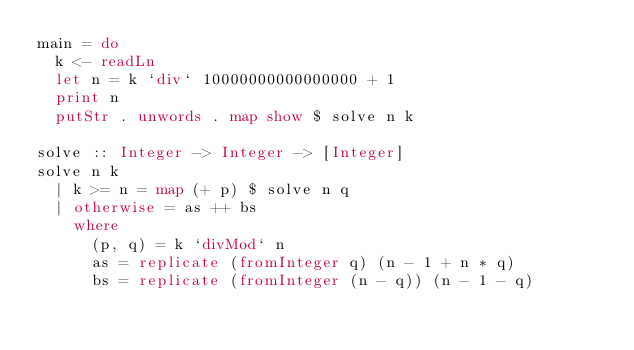<code> <loc_0><loc_0><loc_500><loc_500><_Haskell_>main = do
  k <- readLn
  let n = k `div` 10000000000000000 + 1
  print n
  putStr . unwords . map show $ solve n k
 
solve :: Integer -> Integer -> [Integer]
solve n k
  | k >= n = map (+ p) $ solve n q 
  | otherwise = as ++ bs
    where
      (p, q) = k `divMod` n
      as = replicate (fromInteger q) (n - 1 + n * q)
      bs = replicate (fromInteger (n - q)) (n - 1 - q)</code> 